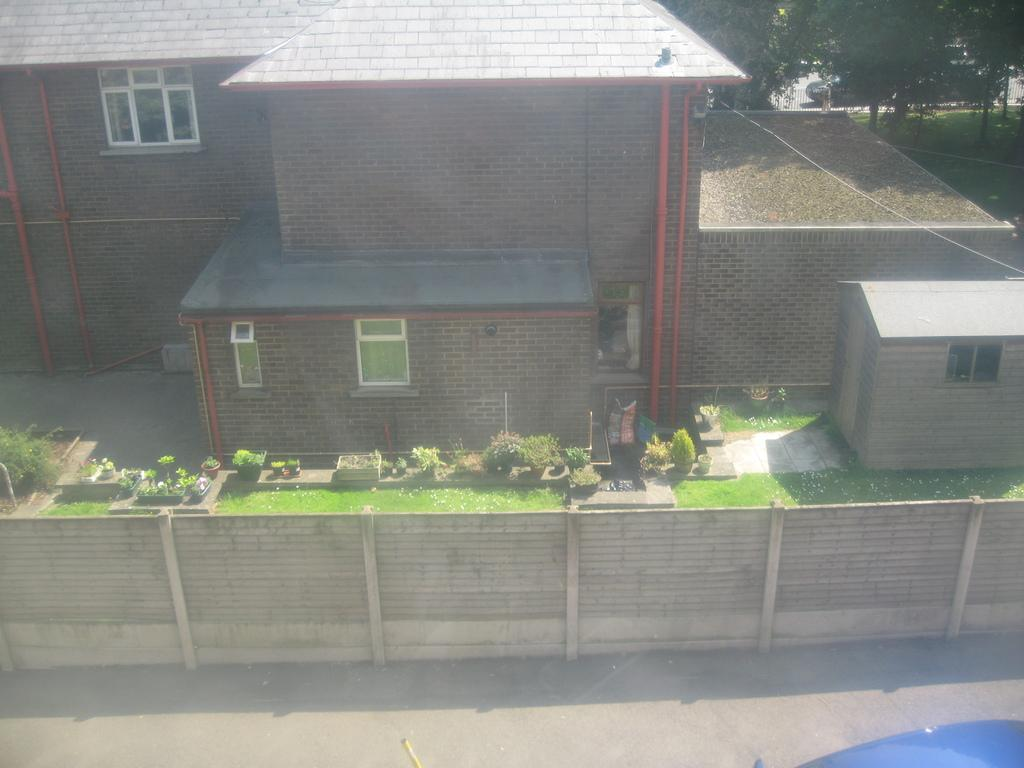What is on the road in the image? There is a vehicle on the road in the image. What can be seen near the road in the image? There is a fence in the image. What type of vegetation is present in the image? There are plants in the image. What type of structure is visible in the image? There is a house with windows in the image. What type of man-made objects can be seen in the image? There are pipes in the image. What can be seen in the distance in the image? There are trees visible in the background of the image. What type of corn is growing in the image? There is no corn present in the image. What color is the paint on the house in the image? The provided facts do not mention the color of the house, so we cannot determine the paint color from the image. 